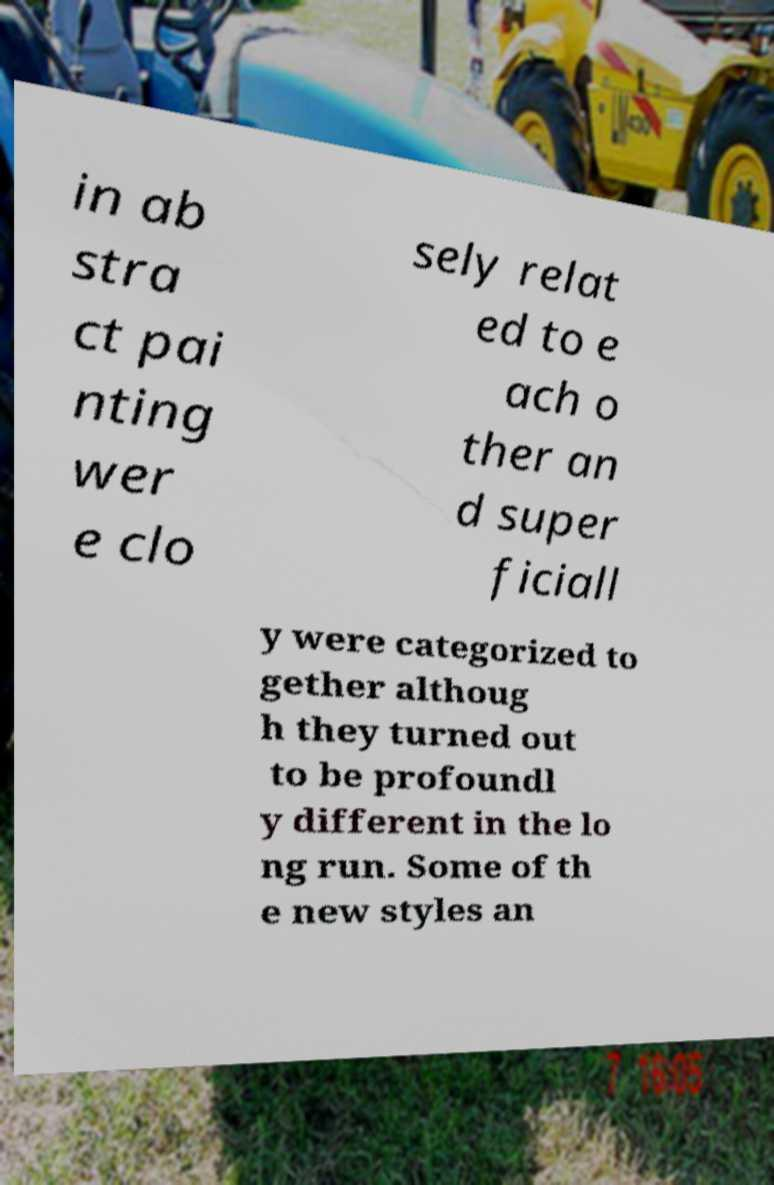I need the written content from this picture converted into text. Can you do that? in ab stra ct pai nting wer e clo sely relat ed to e ach o ther an d super ficiall y were categorized to gether althoug h they turned out to be profoundl y different in the lo ng run. Some of th e new styles an 